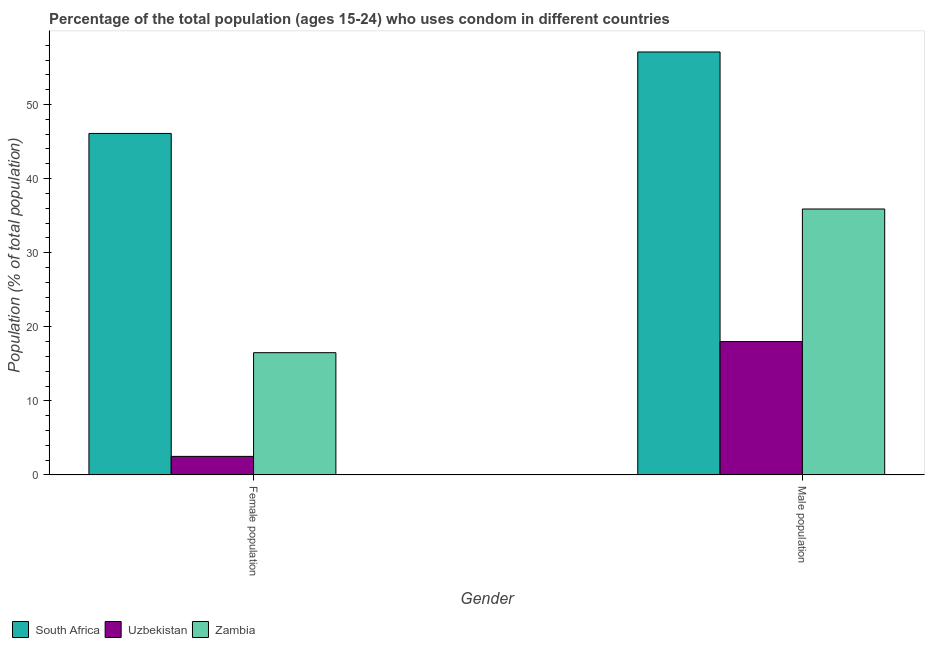How many different coloured bars are there?
Ensure brevity in your answer.  3. How many groups of bars are there?
Provide a short and direct response. 2. Are the number of bars on each tick of the X-axis equal?
Your answer should be very brief. Yes. How many bars are there on the 1st tick from the left?
Make the answer very short. 3. How many bars are there on the 1st tick from the right?
Ensure brevity in your answer.  3. What is the label of the 1st group of bars from the left?
Offer a terse response. Female population. What is the male population in Zambia?
Make the answer very short. 35.9. Across all countries, what is the maximum female population?
Offer a terse response. 46.1. Across all countries, what is the minimum male population?
Provide a short and direct response. 18. In which country was the male population maximum?
Make the answer very short. South Africa. In which country was the male population minimum?
Provide a short and direct response. Uzbekistan. What is the total male population in the graph?
Offer a very short reply. 111. What is the difference between the male population in Zambia and that in South Africa?
Provide a short and direct response. -21.2. What is the difference between the female population in South Africa and the male population in Zambia?
Give a very brief answer. 10.2. What is the ratio of the male population in Zambia to that in Uzbekistan?
Make the answer very short. 1.99. In how many countries, is the female population greater than the average female population taken over all countries?
Offer a terse response. 1. What does the 1st bar from the left in Male population represents?
Your answer should be compact. South Africa. What does the 1st bar from the right in Female population represents?
Your response must be concise. Zambia. Where does the legend appear in the graph?
Your response must be concise. Bottom left. How are the legend labels stacked?
Make the answer very short. Horizontal. What is the title of the graph?
Ensure brevity in your answer.  Percentage of the total population (ages 15-24) who uses condom in different countries. What is the label or title of the Y-axis?
Provide a succinct answer. Population (% of total population) . What is the Population (% of total population)  of South Africa in Female population?
Provide a succinct answer. 46.1. What is the Population (% of total population)  in Uzbekistan in Female population?
Offer a terse response. 2.5. What is the Population (% of total population)  of Zambia in Female population?
Keep it short and to the point. 16.5. What is the Population (% of total population)  of South Africa in Male population?
Ensure brevity in your answer.  57.1. What is the Population (% of total population)  in Zambia in Male population?
Keep it short and to the point. 35.9. Across all Gender, what is the maximum Population (% of total population)  of South Africa?
Your answer should be compact. 57.1. Across all Gender, what is the maximum Population (% of total population)  in Uzbekistan?
Offer a terse response. 18. Across all Gender, what is the maximum Population (% of total population)  of Zambia?
Provide a short and direct response. 35.9. Across all Gender, what is the minimum Population (% of total population)  in South Africa?
Keep it short and to the point. 46.1. Across all Gender, what is the minimum Population (% of total population)  in Uzbekistan?
Offer a very short reply. 2.5. What is the total Population (% of total population)  in South Africa in the graph?
Make the answer very short. 103.2. What is the total Population (% of total population)  in Zambia in the graph?
Provide a succinct answer. 52.4. What is the difference between the Population (% of total population)  of Uzbekistan in Female population and that in Male population?
Provide a succinct answer. -15.5. What is the difference between the Population (% of total population)  of Zambia in Female population and that in Male population?
Give a very brief answer. -19.4. What is the difference between the Population (% of total population)  of South Africa in Female population and the Population (% of total population)  of Uzbekistan in Male population?
Your answer should be very brief. 28.1. What is the difference between the Population (% of total population)  of South Africa in Female population and the Population (% of total population)  of Zambia in Male population?
Give a very brief answer. 10.2. What is the difference between the Population (% of total population)  of Uzbekistan in Female population and the Population (% of total population)  of Zambia in Male population?
Ensure brevity in your answer.  -33.4. What is the average Population (% of total population)  of South Africa per Gender?
Keep it short and to the point. 51.6. What is the average Population (% of total population)  in Uzbekistan per Gender?
Provide a short and direct response. 10.25. What is the average Population (% of total population)  in Zambia per Gender?
Your answer should be very brief. 26.2. What is the difference between the Population (% of total population)  in South Africa and Population (% of total population)  in Uzbekistan in Female population?
Provide a short and direct response. 43.6. What is the difference between the Population (% of total population)  of South Africa and Population (% of total population)  of Zambia in Female population?
Keep it short and to the point. 29.6. What is the difference between the Population (% of total population)  in South Africa and Population (% of total population)  in Uzbekistan in Male population?
Give a very brief answer. 39.1. What is the difference between the Population (% of total population)  of South Africa and Population (% of total population)  of Zambia in Male population?
Offer a very short reply. 21.2. What is the difference between the Population (% of total population)  in Uzbekistan and Population (% of total population)  in Zambia in Male population?
Your answer should be very brief. -17.9. What is the ratio of the Population (% of total population)  of South Africa in Female population to that in Male population?
Provide a short and direct response. 0.81. What is the ratio of the Population (% of total population)  of Uzbekistan in Female population to that in Male population?
Offer a terse response. 0.14. What is the ratio of the Population (% of total population)  in Zambia in Female population to that in Male population?
Your answer should be very brief. 0.46. What is the difference between the highest and the lowest Population (% of total population)  of Uzbekistan?
Give a very brief answer. 15.5. 